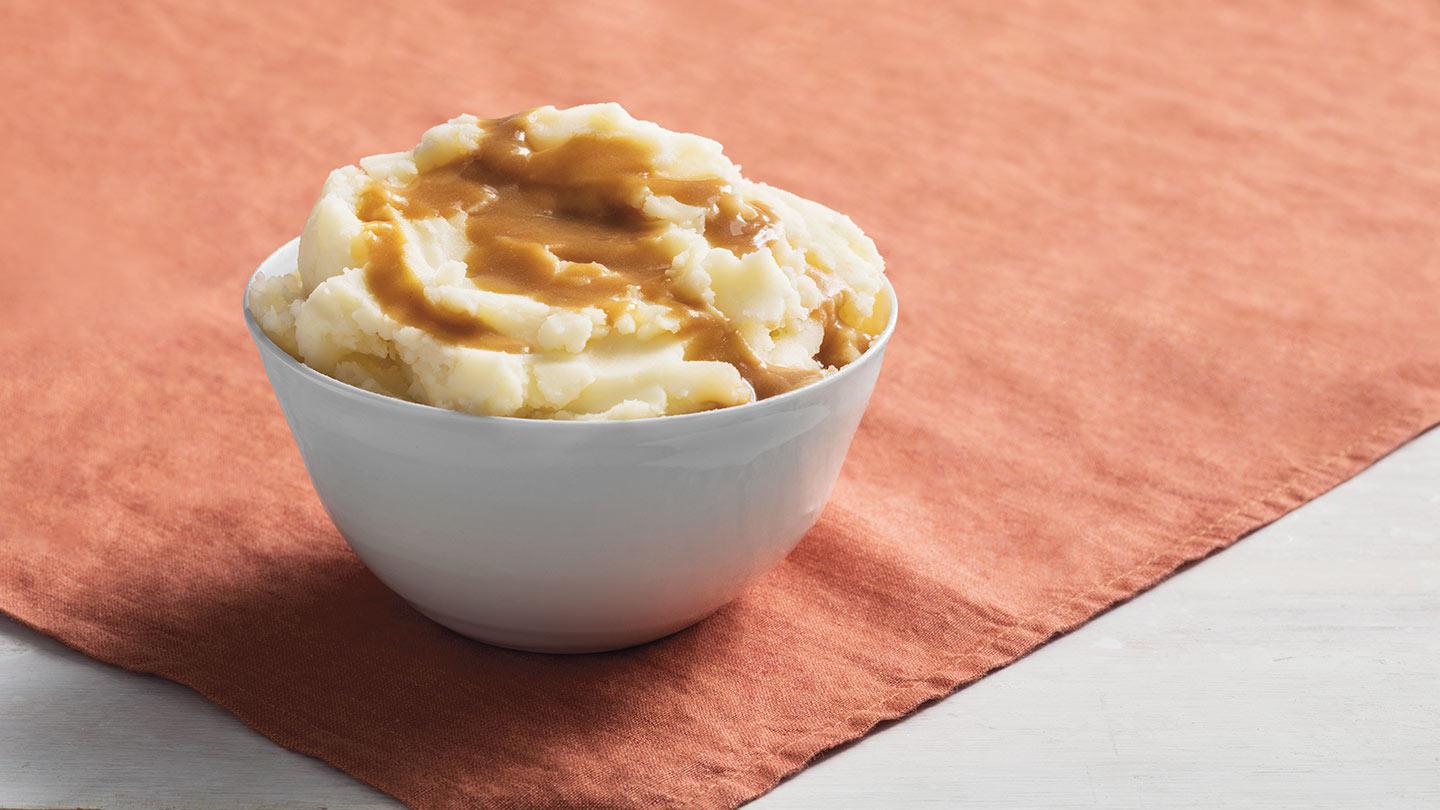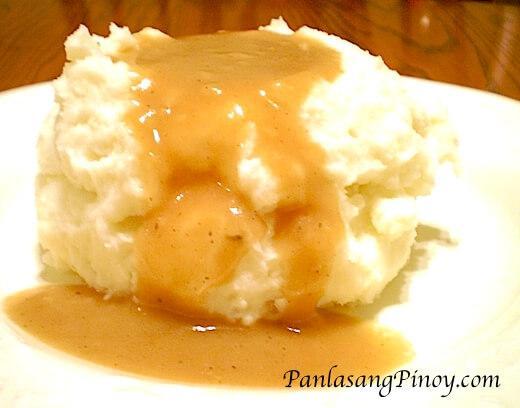The first image is the image on the left, the second image is the image on the right. Assess this claim about the two images: "An eating utensil can be seen in the image on the left.". Correct or not? Answer yes or no. No. 